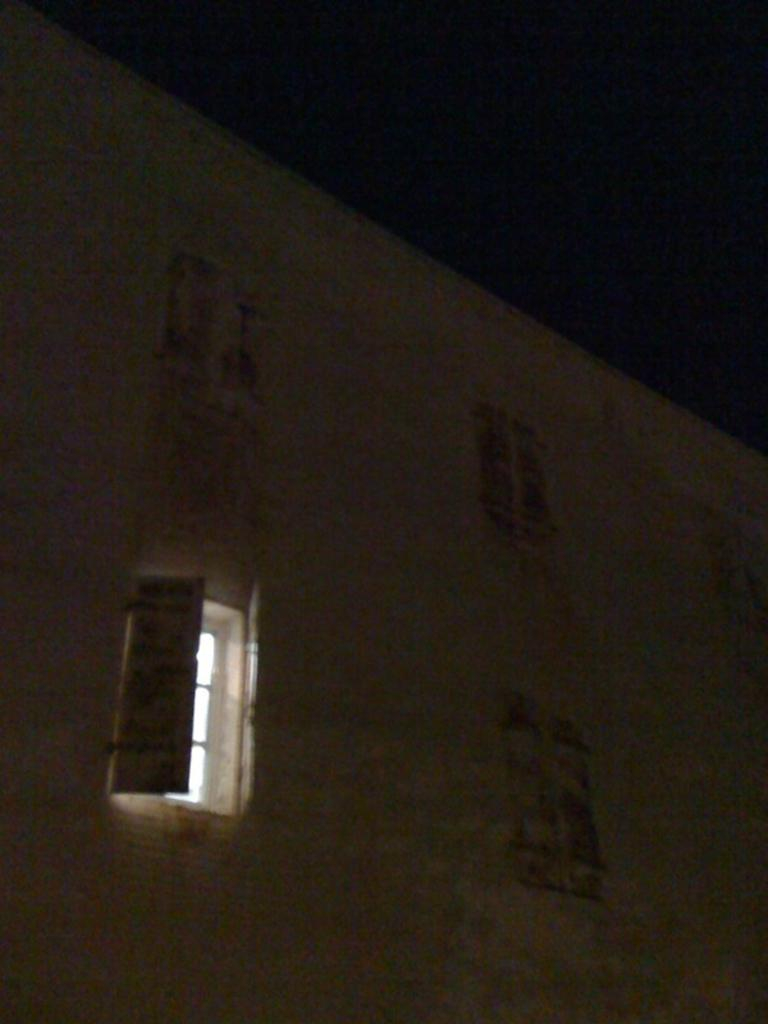What type of structure is present in the image? There is a building in the image. What is the color of the building? The building is white in color. What feature can be seen on the building? The building has windows. What is visible at the top of the image? The sky is visible at the top of the image. What is the color of the sky in the image? The sky is black in color. Based on the color of the sky, what might be the time of day or lighting conditions when the image was taken? The image might have been taken in the dark. What condition is the grandfather in during the image? There is no mention of a grandfather or any person in the image, so it is not possible to answer this question. 